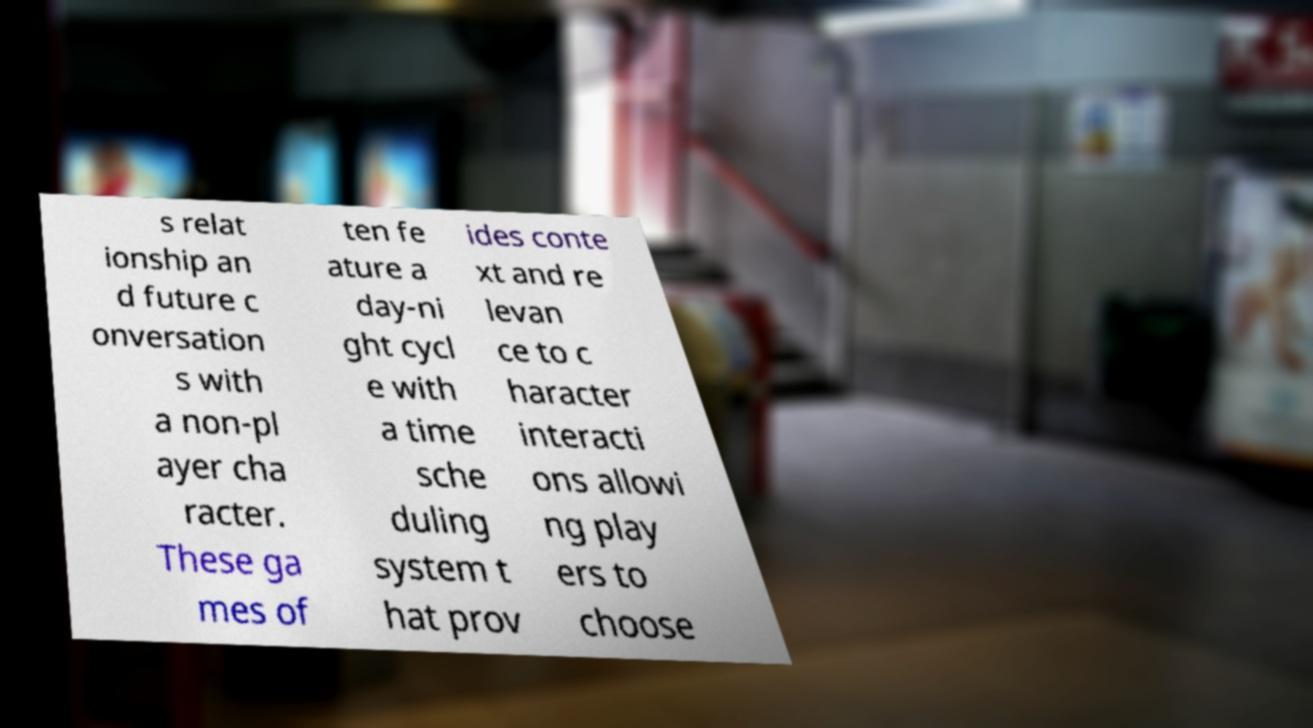Can you accurately transcribe the text from the provided image for me? s relat ionship an d future c onversation s with a non-pl ayer cha racter. These ga mes of ten fe ature a day-ni ght cycl e with a time sche duling system t hat prov ides conte xt and re levan ce to c haracter interacti ons allowi ng play ers to choose 